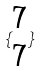<formula> <loc_0><loc_0><loc_500><loc_500>\{ \begin{matrix} 7 \\ 7 \end{matrix} \}</formula> 